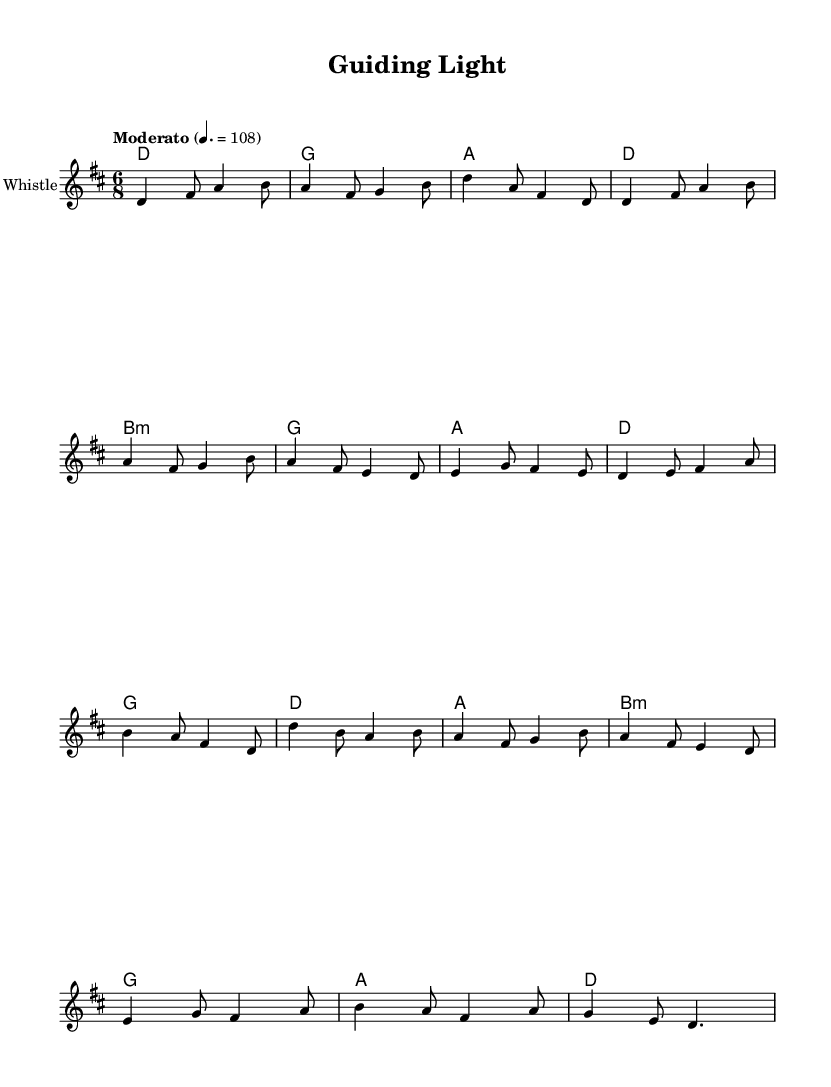What is the key signature of this music? The key signature of the music is D major, which has two sharps (F# and C#). This can be determined from the global settings in the code that specify using \key d \major.
Answer: D major What is the time signature of this music? The time signature is 6/8, indicated in the global settings with \time 6/8. This shows that there are six eighth notes in a measure, which gives the piece a compound feel.
Answer: 6/8 What is the tempo marking for this piece? The tempo marking for the music is "Moderato," indicated by the \tempo command in the global section, which suggests a moderate speed of 108 beats per minute.
Answer: Moderato How many measures are in the verse section? The verse section contains 6 measures, which can be counted from the lines that are labeled as the verse in the melody section of the code.
Answer: 6 What is the first lyric line of the chorus? The first lyric line of the chorus is "Oh, guiding light, show me the way," found in the lyrics mode specified for the chorus. This line indicates the themes of mentorship and guidance.
Answer: Oh, guiding light, show me the way What type of instrument is indicated in the score? The indicated instrument in the score is the "Tin Whistle," as specified in the Staff section of the code. This instrument is commonly associated with folk music, particularly in Celtic traditions.
Answer: Tin Whistle What is the structure type of the song based on the sections? The structure type of the song is Verse-Chorus structure, as seen in the layout of the verses followed by the chorus lyrics, which is a common format in folk music storytelling.
Answer: Verse-Chorus 